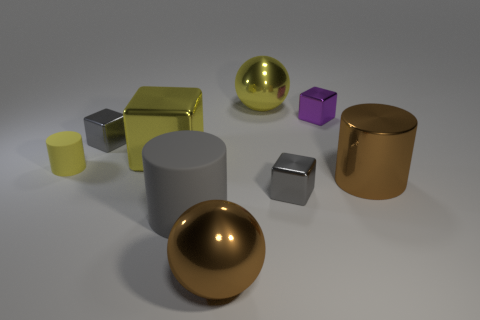Subtract all large brown metal cylinders. How many cylinders are left? 2 Subtract all yellow blocks. How many blocks are left? 3 Subtract all green spheres. How many blue cylinders are left? 0 Subtract all tiny gray metal balls. Subtract all large matte things. How many objects are left? 8 Add 2 cylinders. How many cylinders are left? 5 Add 6 small red spheres. How many small red spheres exist? 6 Subtract 0 red blocks. How many objects are left? 9 Subtract all cylinders. How many objects are left? 6 Subtract 1 balls. How many balls are left? 1 Subtract all cyan balls. Subtract all yellow blocks. How many balls are left? 2 